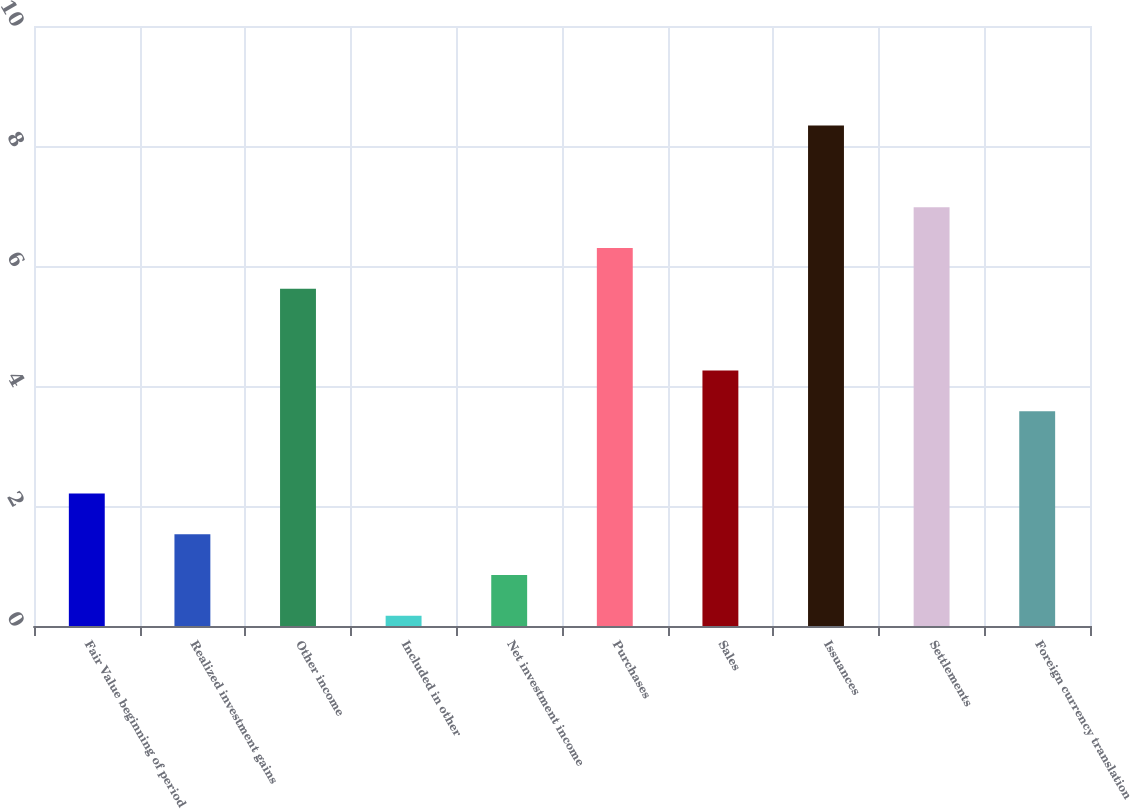Convert chart. <chart><loc_0><loc_0><loc_500><loc_500><bar_chart><fcel>Fair Value beginning of period<fcel>Realized investment gains<fcel>Other income<fcel>Included in other<fcel>Net investment income<fcel>Purchases<fcel>Sales<fcel>Issuances<fcel>Settlements<fcel>Foreign currency translation<nl><fcel>2.21<fcel>1.53<fcel>5.62<fcel>0.17<fcel>0.85<fcel>6.3<fcel>4.26<fcel>8.34<fcel>6.98<fcel>3.58<nl></chart> 